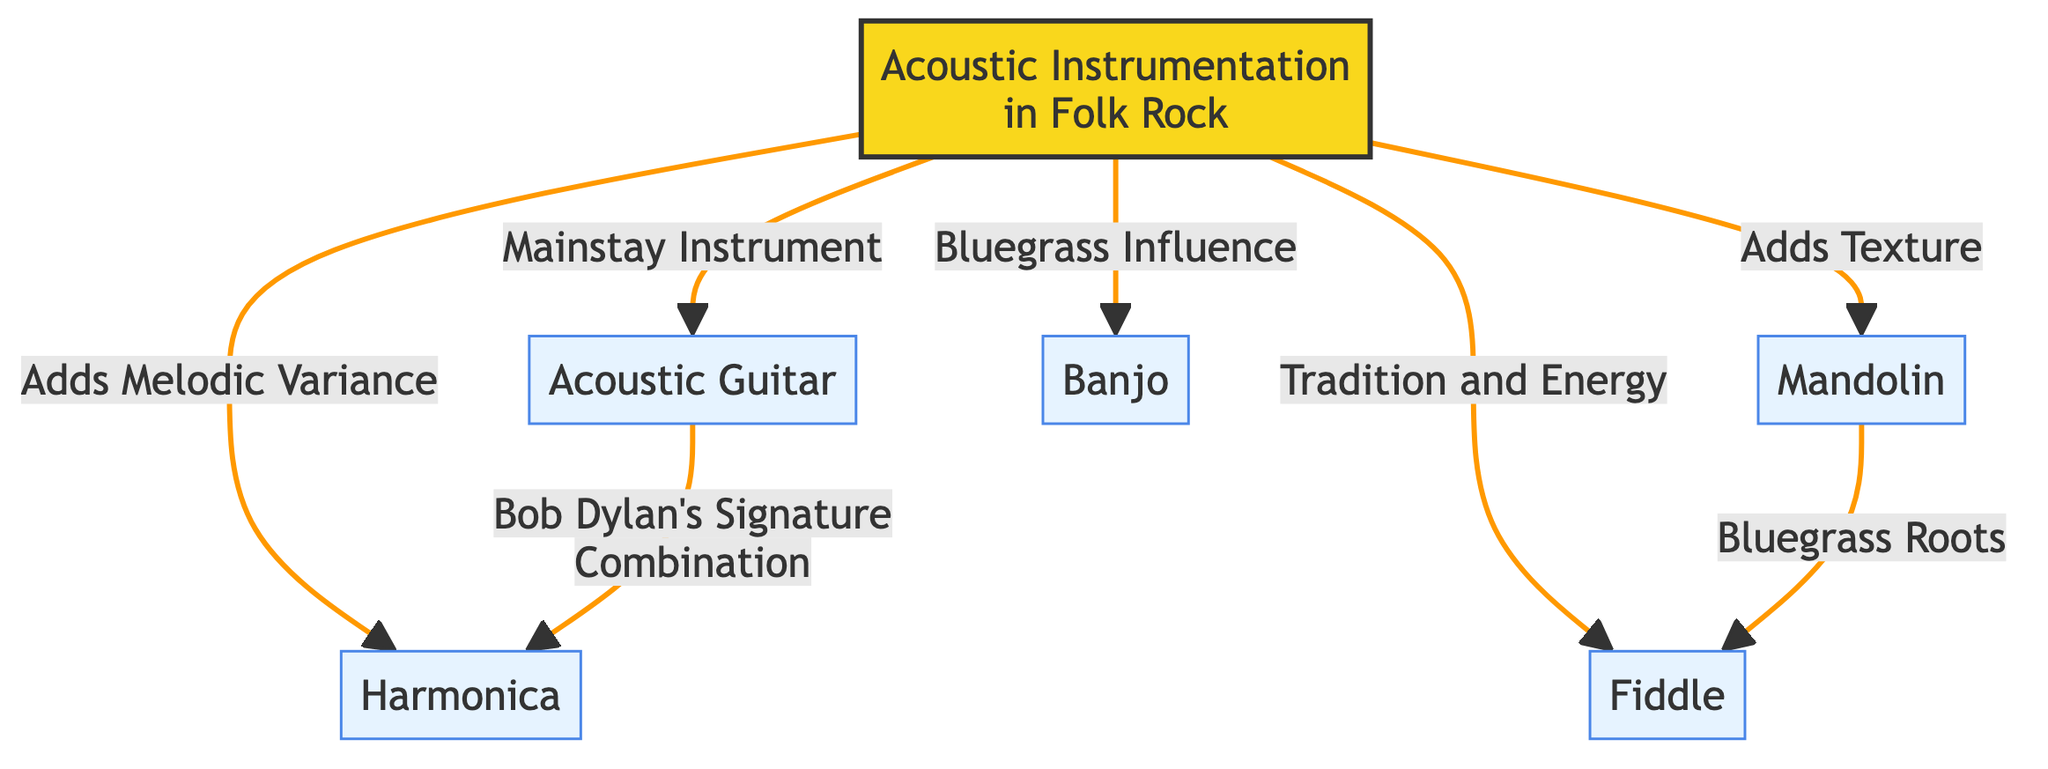What is the mainstay instrument in folk rock? The diagram states that the Acoustic Guitar is labeled as the "Mainstay Instrument" under the node for "Acoustic Instrumentation in Folk Rock." This indicates that of all the instruments listed, the acoustic guitar is the primary one in this genre.
Answer: Acoustic Guitar How many instruments are listed in the diagram? The diagram includes six instruments connected to the main node of "Acoustic Instrumentation in Folk Rock." These instruments are Acoustic Guitar, Mandolin, Banjo, Harmonica, and Fiddle, making a total of five instruments under the main node, plus the acoustic guitar itself. Therefore, the count is six.
Answer: Six Which instrument adds texture to folk rock? The diagram illustrates that the Mandolin adds texture by linking it to the primary "Acoustic Instrumentation in Folk Rock" node with the description "Adds Texture." This indicates its role in enhancing the overall sound within this genre.
Answer: Mandolin What instrument is influenced by bluegrass? The Banjo is explicitly connected to the "Bluegrass Influence" descriptor in the diagram. This indicates that the banjo has significant ties to the bluegrass musical style, making it influenced by bluegrass.
Answer: Banjo Which two instruments are linked through Bob Dylan's signature combination? The diagram shows an arrow from Acoustic Guitar to Harmonica stating "Bob Dylan's Signature Combination," indicating that these two instruments are associated through Bob Dylan's music style. Therefore, the instruments linked through this description are the Acoustic Guitar and Harmonica.
Answer: Acoustic Guitar and Harmonica What role does the Fiddle play in folk rock? The diagram describes the role of the Fiddle as adding "Tradition and Energy" in the framework of Acoustic Instrumentation in Folk Rock. This highlights its significance in providing cultural significance and vigor in folk rock music.
Answer: Tradition and Energy Which instrument is associated with bluegrass roots along with the Fiddle? The diagram indicates a connection between Mandolin and Fiddle by stating "Bluegrass Roots," showing that both instruments share a relationship with bluegrass music origins. Thus, the instrument associated with the Fiddle in this context is the Mandolin.
Answer: Mandolin Which instrument provides melodic variance? According to the diagram, the Harmonica is described as "Adds Melodic Variance" under the primary node of Acoustic Instrumentation in Folk Rock. This clearly indicates its contribution to the dynamics of the music by offering varied melodies.
Answer: Harmonica 